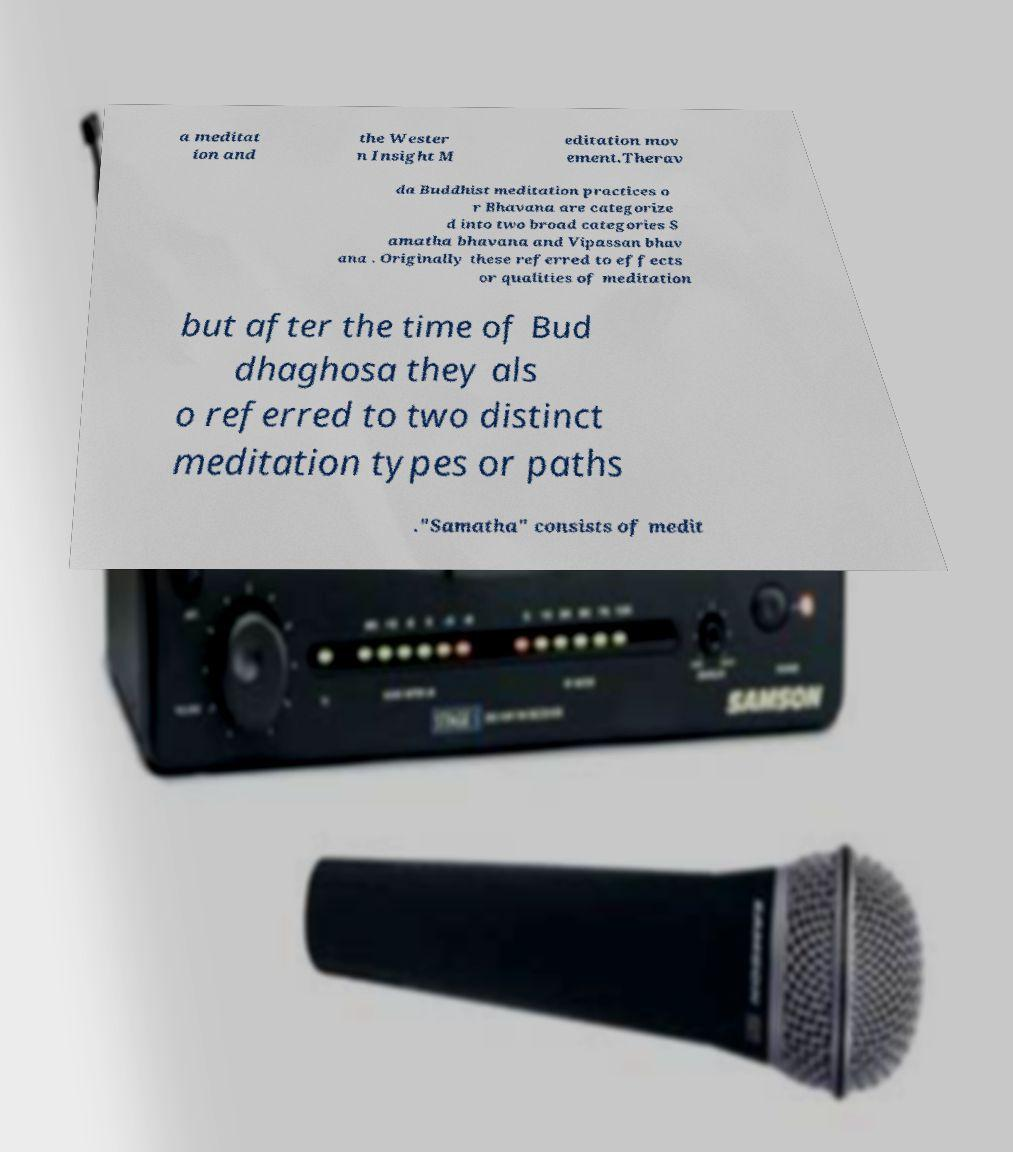Please read and relay the text visible in this image. What does it say? a meditat ion and the Wester n Insight M editation mov ement.Therav da Buddhist meditation practices o r Bhavana are categorize d into two broad categories S amatha bhavana and Vipassan bhav ana . Originally these referred to effects or qualities of meditation but after the time of Bud dhaghosa they als o referred to two distinct meditation types or paths ."Samatha" consists of medit 